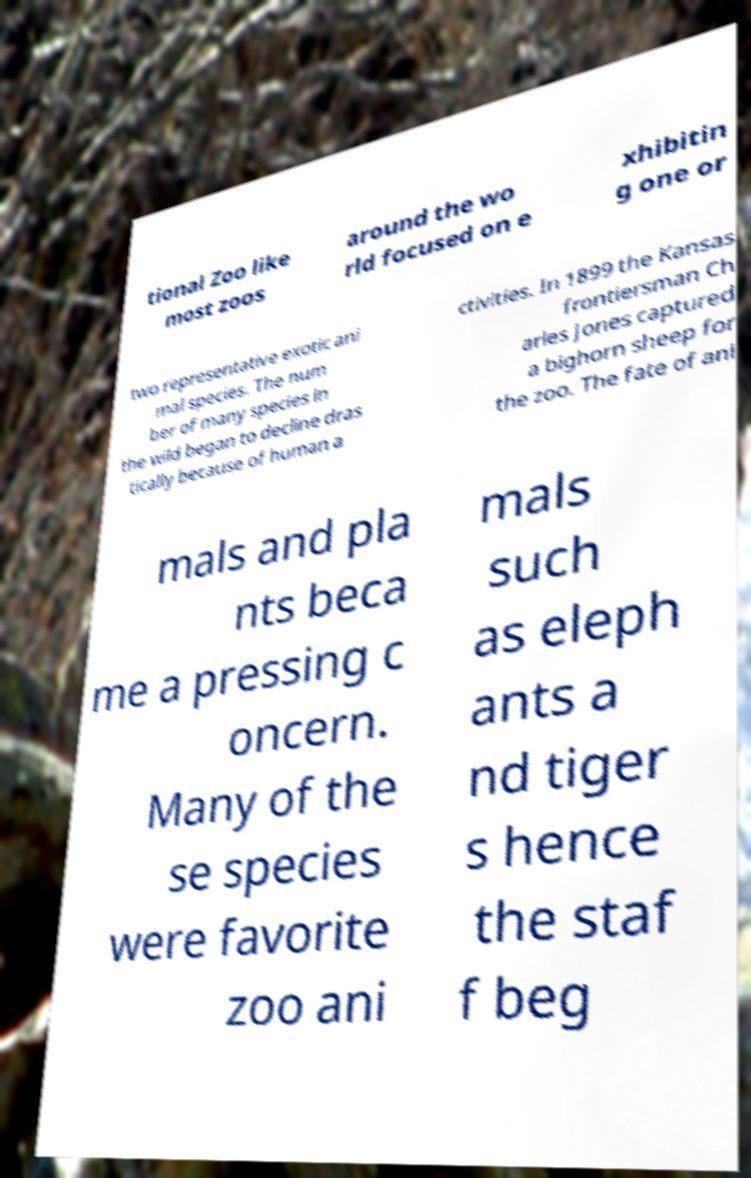Can you read and provide the text displayed in the image?This photo seems to have some interesting text. Can you extract and type it out for me? tional Zoo like most zoos around the wo rld focused on e xhibitin g one or two representative exotic ani mal species. The num ber of many species in the wild began to decline dras tically because of human a ctivities. In 1899 the Kansas frontiersman Ch arles Jones captured a bighorn sheep for the zoo. The fate of ani mals and pla nts beca me a pressing c oncern. Many of the se species were favorite zoo ani mals such as eleph ants a nd tiger s hence the staf f beg 